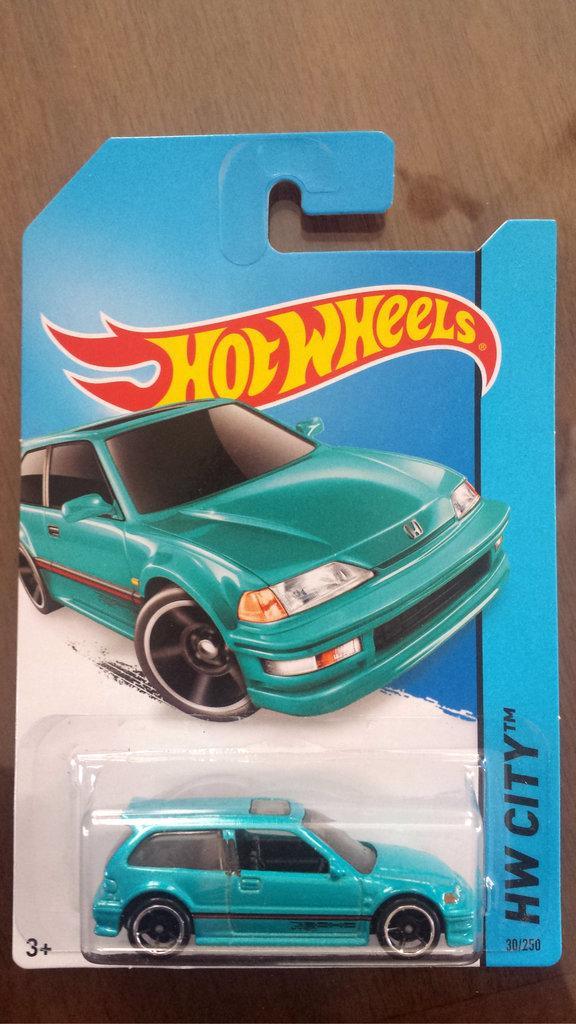In one or two sentences, can you explain what this image depicts? In this picture we can see a toy vehicle and a card with some text on it and in the background we can see a wooden surface. 